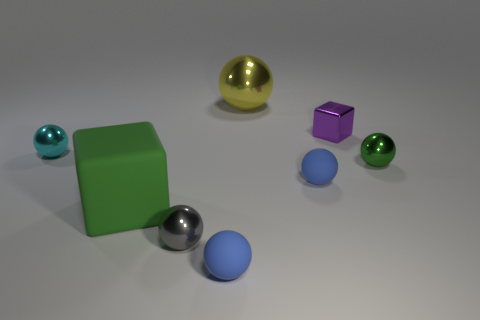What material is the big object that is right of the block in front of the small ball right of the tiny purple shiny object?
Give a very brief answer. Metal. Is the color of the rubber block the same as the large thing that is behind the small cyan shiny ball?
Your response must be concise. No. Are there any other things that have the same shape as the small green metallic thing?
Keep it short and to the point. Yes. What color is the big thing that is in front of the rubber sphere that is on the right side of the large metal ball?
Your answer should be compact. Green. How many cyan spheres are there?
Make the answer very short. 1. How many metal objects are yellow spheres or tiny cyan spheres?
Offer a terse response. 2. What number of other blocks have the same color as the rubber cube?
Give a very brief answer. 0. What is the sphere on the left side of the metal sphere in front of the small green sphere made of?
Provide a succinct answer. Metal. How big is the green metal thing?
Make the answer very short. Small. How many blue matte things have the same size as the gray shiny sphere?
Make the answer very short. 2. 